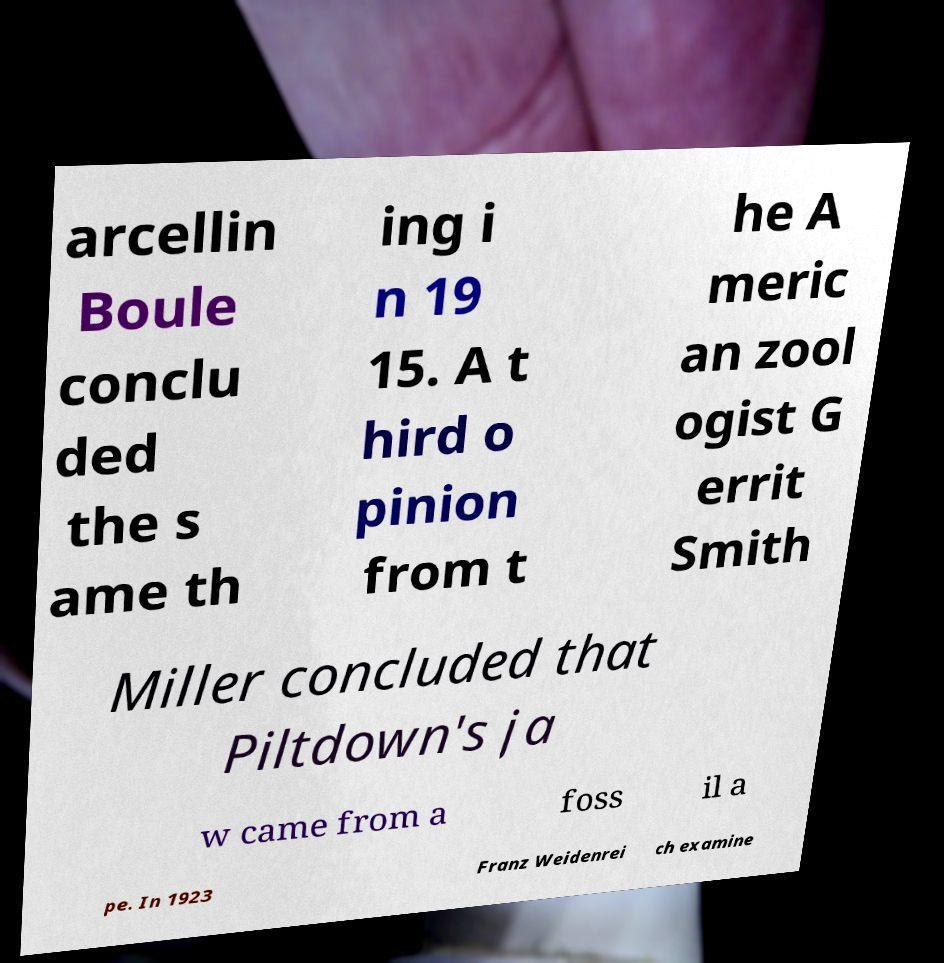There's text embedded in this image that I need extracted. Can you transcribe it verbatim? arcellin Boule conclu ded the s ame th ing i n 19 15. A t hird o pinion from t he A meric an zool ogist G errit Smith Miller concluded that Piltdown's ja w came from a foss il a pe. In 1923 Franz Weidenrei ch examine 